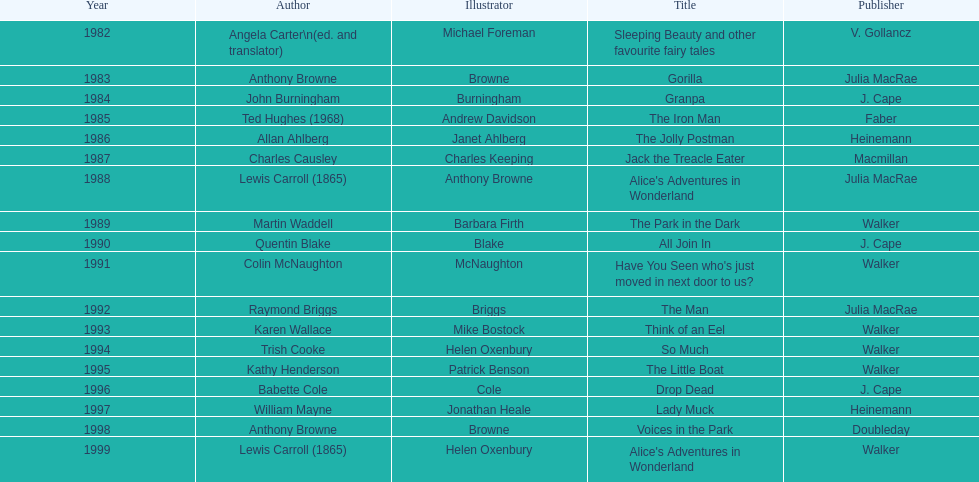What is the only title listed for 1999? Alice's Adventures in Wonderland. Parse the table in full. {'header': ['Year', 'Author', 'Illustrator', 'Title', 'Publisher'], 'rows': [['1982', 'Angela Carter\\n(ed. and translator)', 'Michael Foreman', 'Sleeping Beauty and other favourite fairy tales', 'V. Gollancz'], ['1983', 'Anthony Browne', 'Browne', 'Gorilla', 'Julia MacRae'], ['1984', 'John Burningham', 'Burningham', 'Granpa', 'J. Cape'], ['1985', 'Ted Hughes (1968)', 'Andrew Davidson', 'The Iron Man', 'Faber'], ['1986', 'Allan Ahlberg', 'Janet Ahlberg', 'The Jolly Postman', 'Heinemann'], ['1987', 'Charles Causley', 'Charles Keeping', 'Jack the Treacle Eater', 'Macmillan'], ['1988', 'Lewis Carroll (1865)', 'Anthony Browne', "Alice's Adventures in Wonderland", 'Julia MacRae'], ['1989', 'Martin Waddell', 'Barbara Firth', 'The Park in the Dark', 'Walker'], ['1990', 'Quentin Blake', 'Blake', 'All Join In', 'J. Cape'], ['1991', 'Colin McNaughton', 'McNaughton', "Have You Seen who's just moved in next door to us?", 'Walker'], ['1992', 'Raymond Briggs', 'Briggs', 'The Man', 'Julia MacRae'], ['1993', 'Karen Wallace', 'Mike Bostock', 'Think of an Eel', 'Walker'], ['1994', 'Trish Cooke', 'Helen Oxenbury', 'So Much', 'Walker'], ['1995', 'Kathy Henderson', 'Patrick Benson', 'The Little Boat', 'Walker'], ['1996', 'Babette Cole', 'Cole', 'Drop Dead', 'J. Cape'], ['1997', 'William Mayne', 'Jonathan Heale', 'Lady Muck', 'Heinemann'], ['1998', 'Anthony Browne', 'Browne', 'Voices in the Park', 'Doubleday'], ['1999', 'Lewis Carroll (1865)', 'Helen Oxenbury', "Alice's Adventures in Wonderland", 'Walker']]} 